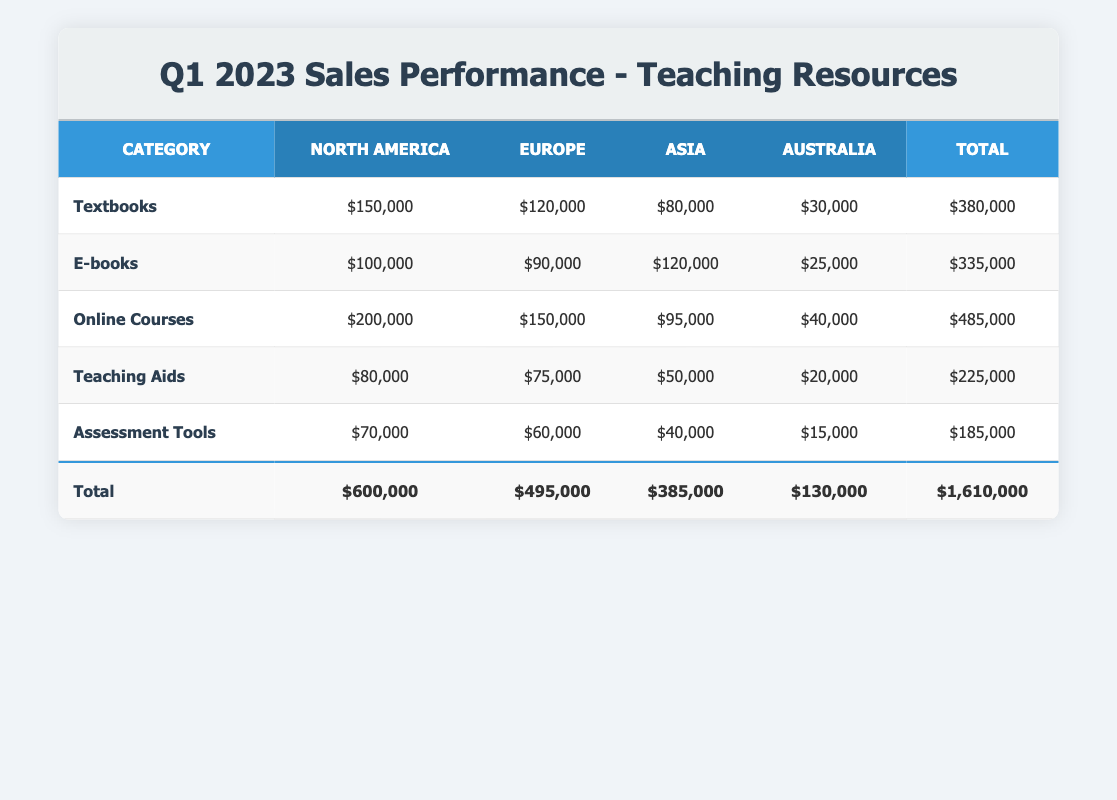What is the total sales for Online Courses in North America? The sales data shows that the sales for Online Courses in North America is $200,000.
Answer: $200,000 Which category had the highest sales in Europe? Looking at the Europe column, Online Courses has the highest sales of $150,000 compared to other categories: Textbooks ($120,000), E-books ($90,000), Teaching Aids ($75,000), and Assessment Tools ($60,000).
Answer: Online Courses What is the total sales for all categories in Australia? To find the total sales in Australia, add the sales for all categories: $30,000 (Textbooks) + $25,000 (E-books) + $40,000 (Online Courses) + $20,000 (Teaching Aids) + $15,000 (Assessment Tools) = $130,000.
Answer: $130,000 Is it true that Assessment Tools had higher sales in Asia than E-books? The sales data shows Assessment Tools had $40,000 in Asia, while E-books had $120,000. Therefore, it is false that Assessment Tools had higher sales.
Answer: No What is the difference in total sales between North America and Europe? To calculate the difference, first sum the total sales for each region: North America total is $600,000, and Europe total is $495,000. The difference is $600,000 - $495,000 = $105,000.
Answer: $105,000 Which region had the lowest sales for Teaching Aids? By examining the sales data for Teaching Aids, we see Australia with sales of $20,000, which is lower than North America ($80,000), Europe ($75,000), and Asia ($50,000).
Answer: Australia What is the average sales for all categories in Asia? To find the average sales in Asia, sum the sales for all categories: $80,000 (Textbooks) + $120,000 (E-books) + $95,000 (Online Courses) + $50,000 (Teaching Aids) + $40,000 (Assessment Tools) = $385,000. Then, divide by the number of categories (5): $385,000 / 5 = $77,000.
Answer: $77,000 Which category had overall the lowest sales? The total sales for each category are: Textbooks ($380,000), E-books ($335,000), Online Courses ($485,000), Teaching Aids ($225,000), and Assessment Tools ($185,000). Thus, the category with the lowest overall sales is Assessment Tools with $185,000.
Answer: Assessment Tools 